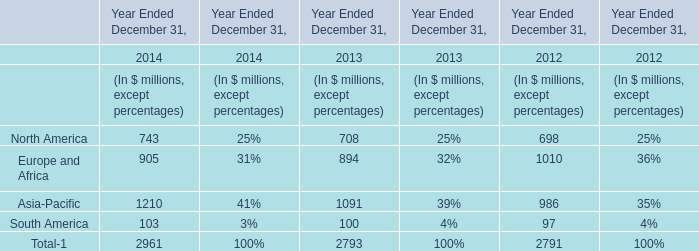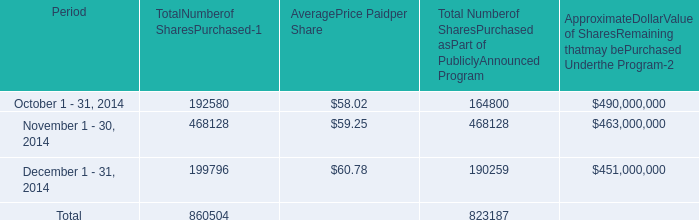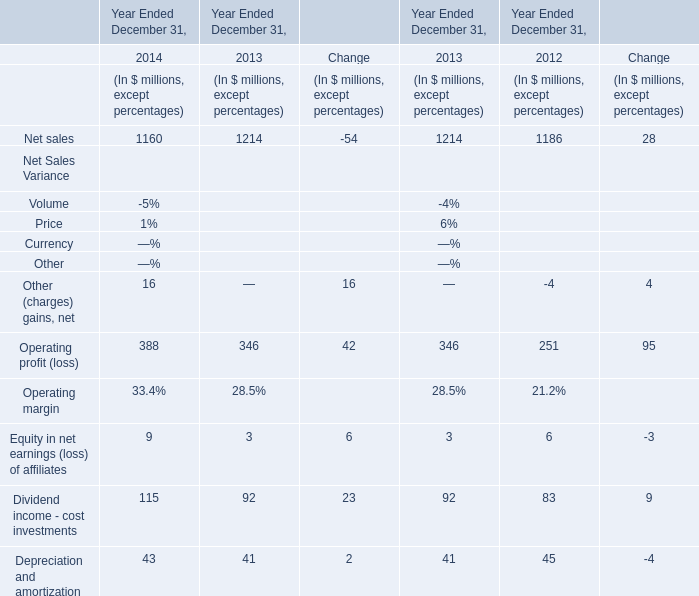If net sales develops with the same growth rate in 2014, what will it reach in 2015? (in million) 
Computations: ((((1160 - 1214) / 1160) + 1) * 1160)
Answer: 1106.0. 